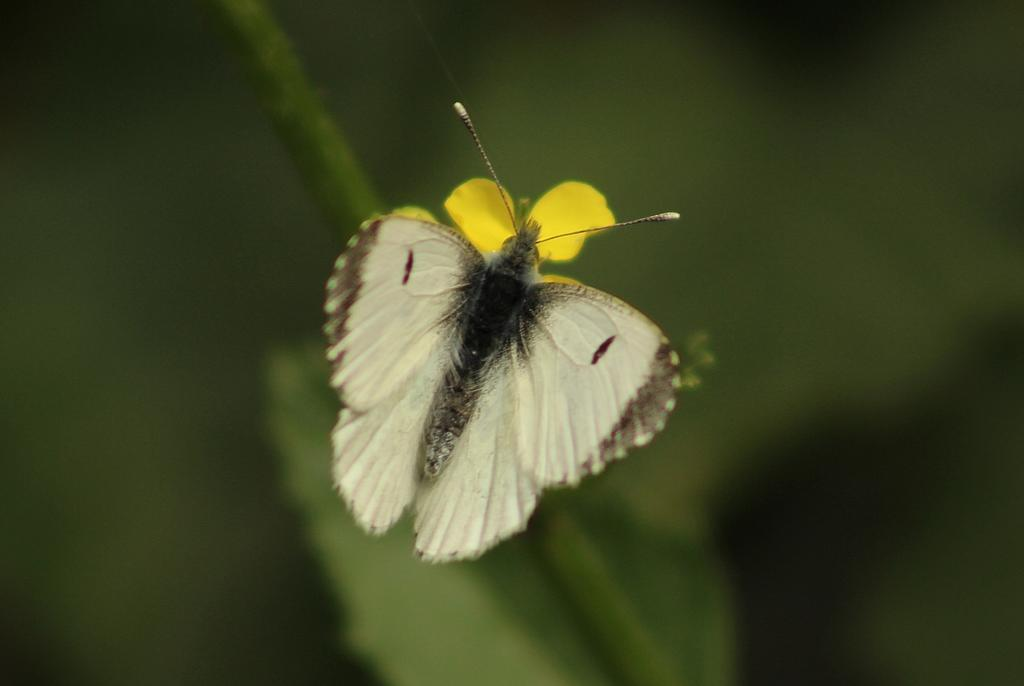What is present in the image? There is an insect in the image. Can you describe the insect's appearance? The insect has cream, brown, and black colors. Where is the insect located in the image? The insect is on a flower. What color is the flower? The flower is yellow in color. How would you describe the background of the image? The background of the image is green and blurry. What type of art can be seen hanging on the wall behind the insect in the image? There is no art or wall visible in the image; it features an insect on a yellow flower with a green and blurry background. 